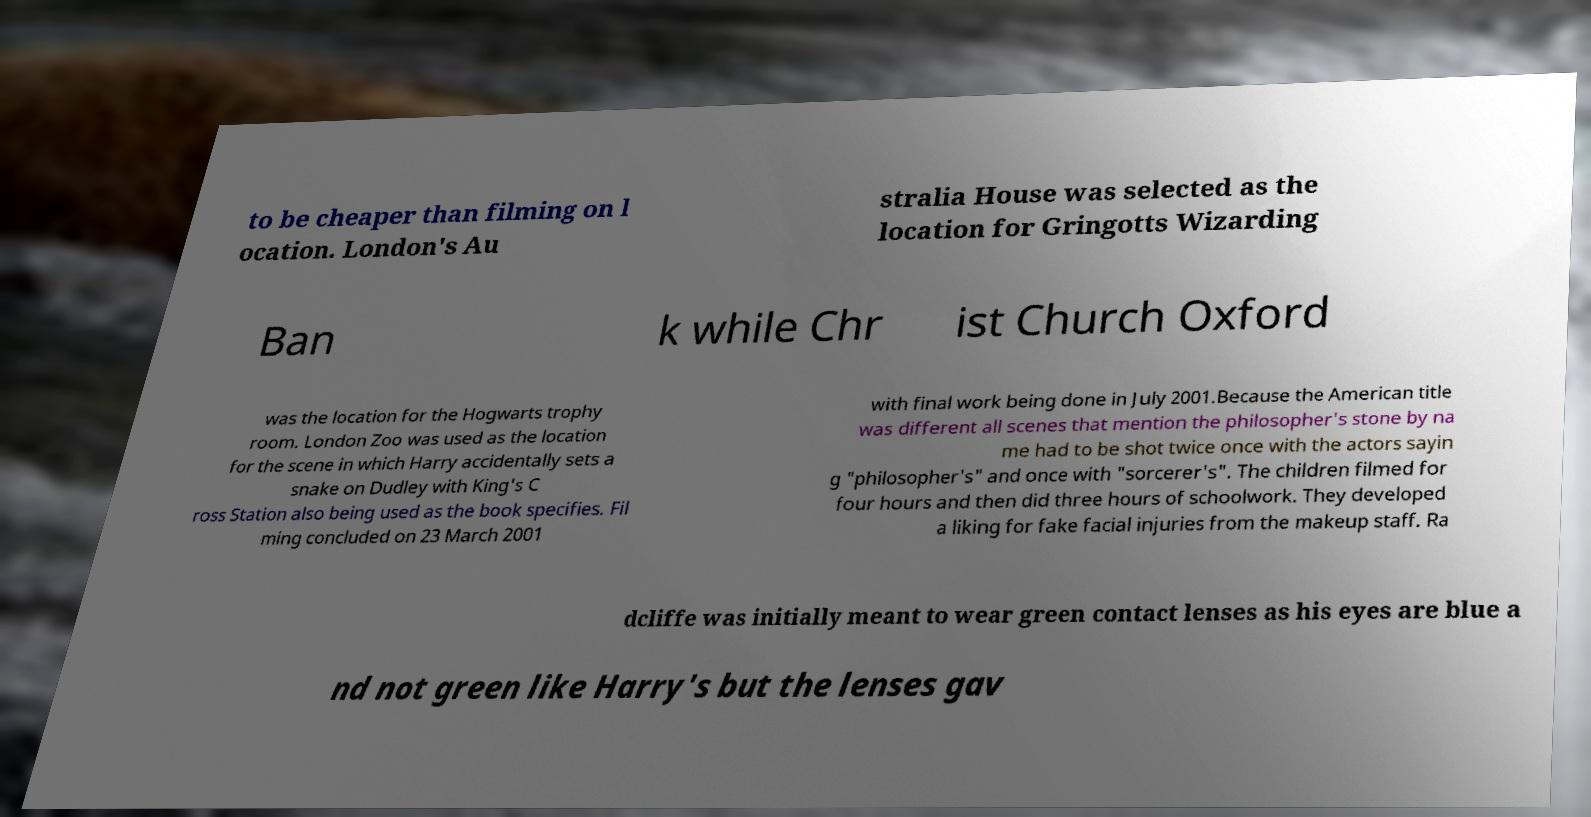Please read and relay the text visible in this image. What does it say? to be cheaper than filming on l ocation. London's Au stralia House was selected as the location for Gringotts Wizarding Ban k while Chr ist Church Oxford was the location for the Hogwarts trophy room. London Zoo was used as the location for the scene in which Harry accidentally sets a snake on Dudley with King's C ross Station also being used as the book specifies. Fil ming concluded on 23 March 2001 with final work being done in July 2001.Because the American title was different all scenes that mention the philosopher's stone by na me had to be shot twice once with the actors sayin g "philosopher's" and once with "sorcerer's". The children filmed for four hours and then did three hours of schoolwork. They developed a liking for fake facial injuries from the makeup staff. Ra dcliffe was initially meant to wear green contact lenses as his eyes are blue a nd not green like Harry's but the lenses gav 